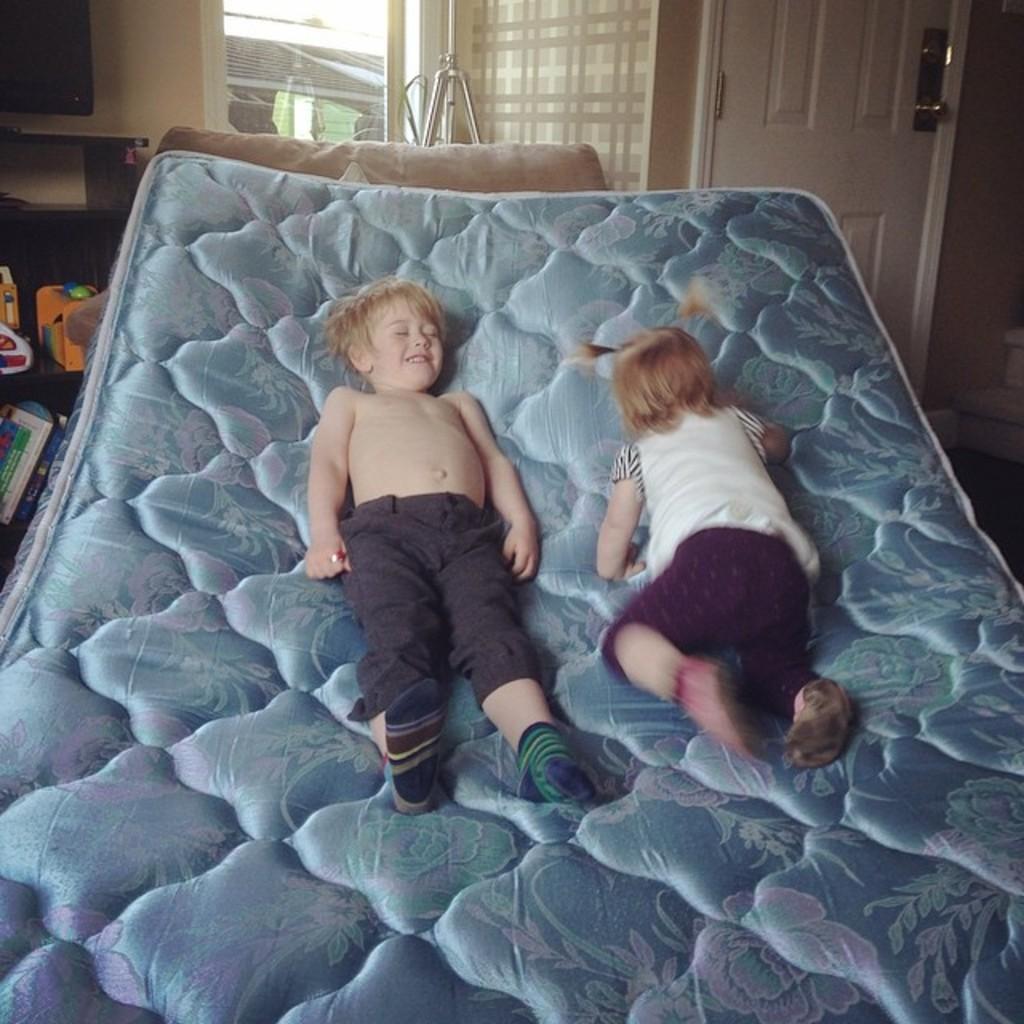Could you give a brief overview of what you see in this image? In the image we can see there are kids who are lying on the mattress. 